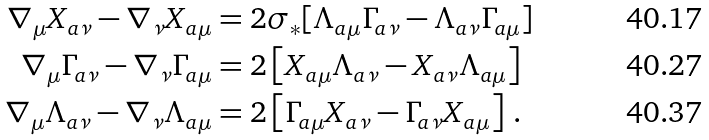<formula> <loc_0><loc_0><loc_500><loc_500>\nabla _ { \mu } X _ { a \nu } - \nabla _ { \nu } X _ { a \mu } & = 2 \sigma _ { \ast } [ \Lambda _ { a \mu } \Gamma _ { a \nu } - \Lambda _ { a \nu } \Gamma _ { a \mu } ] \\ \nabla _ { \mu } \Gamma _ { a \nu } - \nabla _ { \nu } \Gamma _ { a \mu } & = 2 \left [ X _ { a \mu } \Lambda _ { a \nu } - X _ { a \nu } \Lambda _ { a \mu } \right ] \\ \nabla _ { \mu } \Lambda _ { a \nu } - \nabla _ { \nu } \Lambda _ { a \mu } & = 2 \left [ \Gamma _ { a \mu } X _ { a \nu } - \Gamma _ { a \nu } X _ { a \mu } \right ] \, .</formula> 